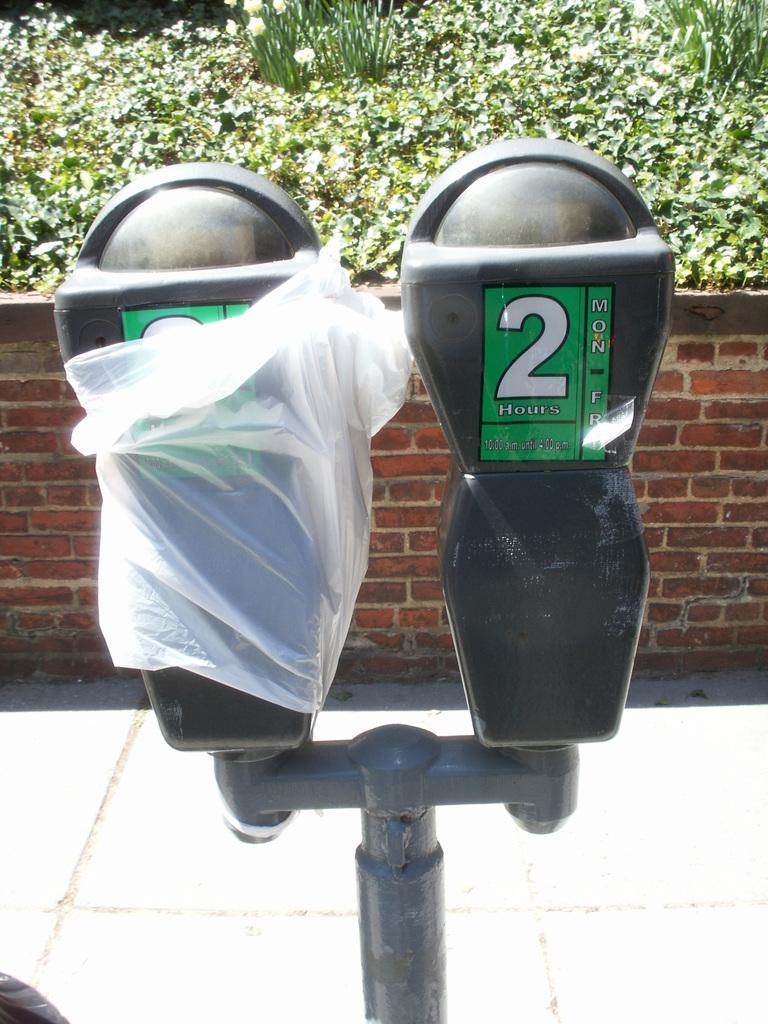Provide a one-sentence caption for the provided image. Two parking meters are side by side and the one on the right only allows for 2 hour parking. 